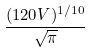<formula> <loc_0><loc_0><loc_500><loc_500>\frac { ( 1 2 0 V ) ^ { 1 / 1 0 } } { \sqrt { \pi } }</formula> 